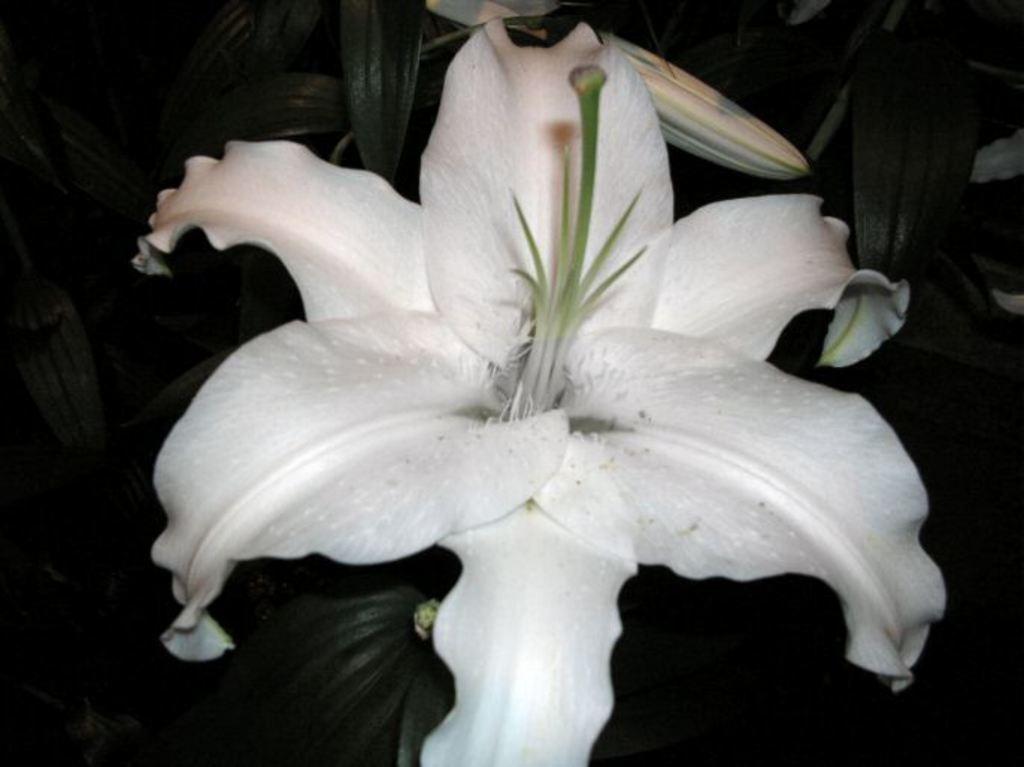Please provide a concise description of this image. There is a flower in the middle of this image and we can see the leaves in the background. 